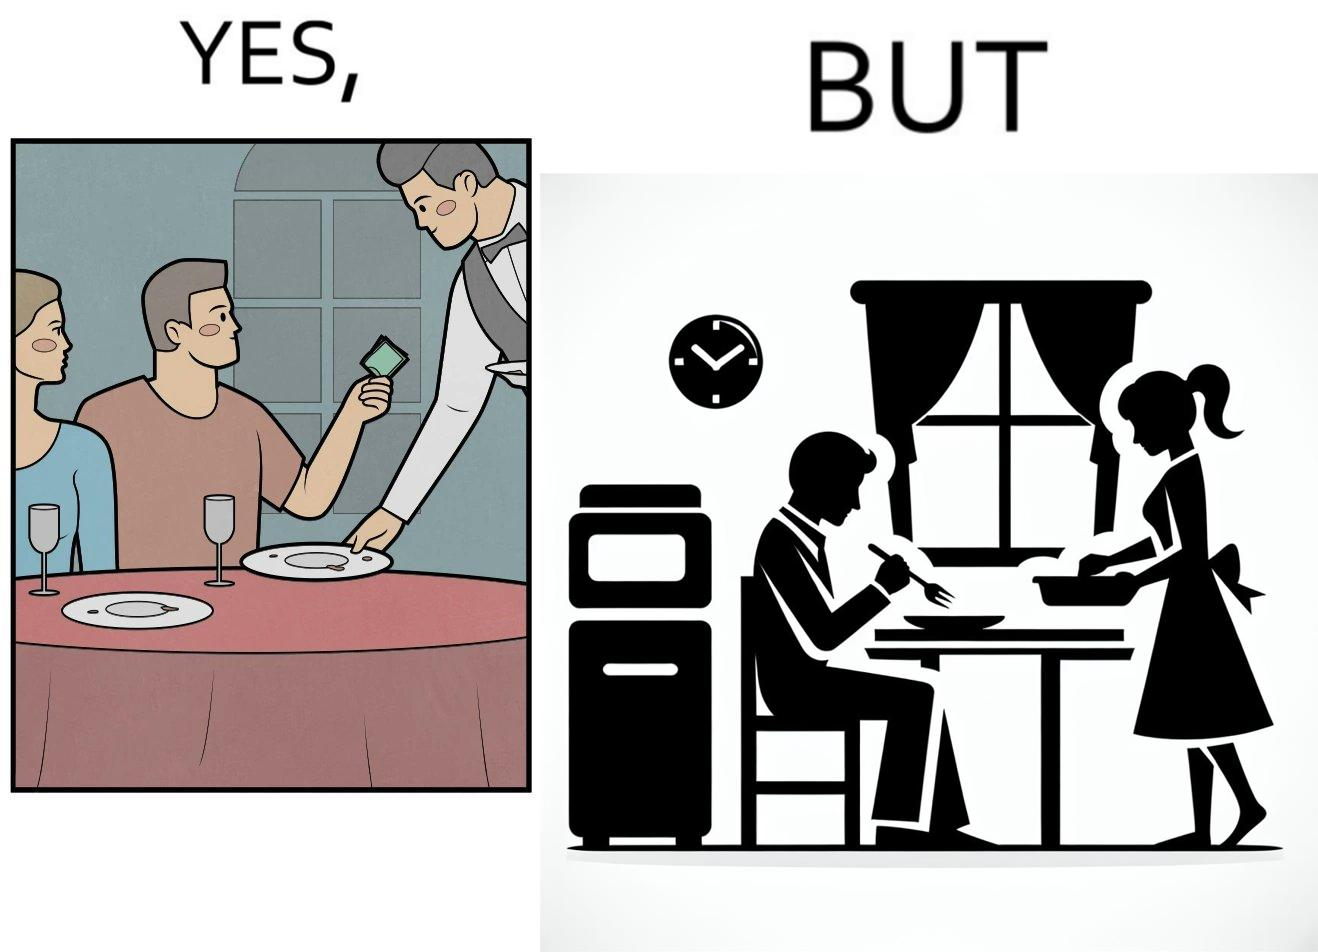Is this image satirical or non-satirical? Yes, this image is satirical. 